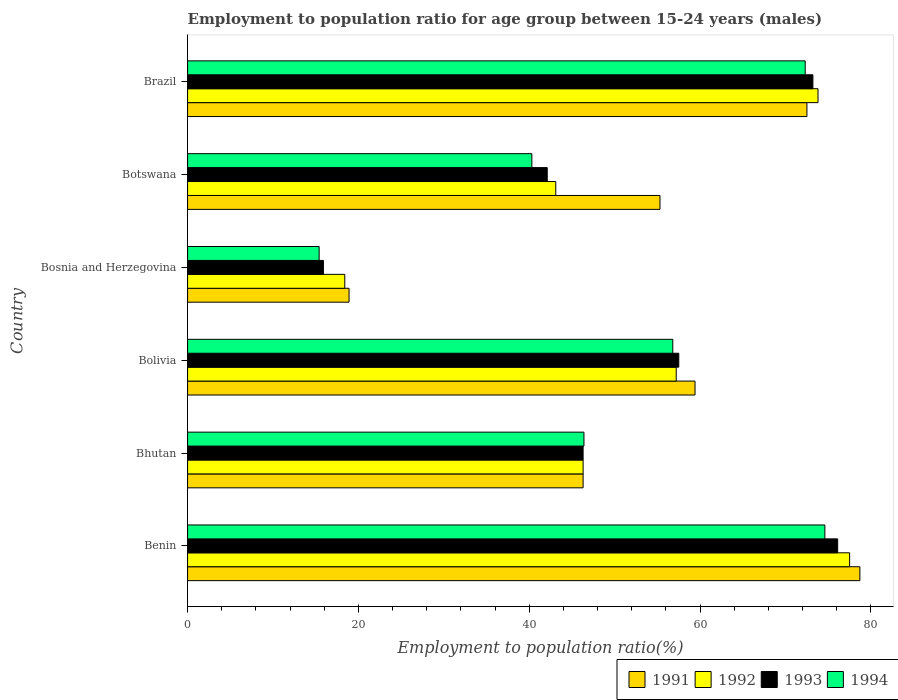How many groups of bars are there?
Keep it short and to the point. 6. How many bars are there on the 6th tick from the bottom?
Your answer should be very brief. 4. What is the label of the 3rd group of bars from the top?
Keep it short and to the point. Bosnia and Herzegovina. In how many cases, is the number of bars for a given country not equal to the number of legend labels?
Your answer should be compact. 0. What is the employment to population ratio in 1994 in Bolivia?
Provide a short and direct response. 56.8. Across all countries, what is the maximum employment to population ratio in 1994?
Provide a short and direct response. 74.6. Across all countries, what is the minimum employment to population ratio in 1992?
Provide a succinct answer. 18.4. In which country was the employment to population ratio in 1992 maximum?
Provide a short and direct response. Benin. In which country was the employment to population ratio in 1992 minimum?
Give a very brief answer. Bosnia and Herzegovina. What is the total employment to population ratio in 1992 in the graph?
Provide a succinct answer. 316.3. What is the difference between the employment to population ratio in 1994 in Bhutan and that in Botswana?
Give a very brief answer. 6.1. What is the difference between the employment to population ratio in 1992 in Bhutan and the employment to population ratio in 1991 in Brazil?
Make the answer very short. -26.2. What is the average employment to population ratio in 1992 per country?
Make the answer very short. 52.72. What is the difference between the employment to population ratio in 1994 and employment to population ratio in 1993 in Bosnia and Herzegovina?
Make the answer very short. -0.5. What is the ratio of the employment to population ratio in 1992 in Benin to that in Bolivia?
Your answer should be compact. 1.35. Is the employment to population ratio in 1991 in Bolivia less than that in Botswana?
Offer a terse response. No. Is the difference between the employment to population ratio in 1994 in Bolivia and Bosnia and Herzegovina greater than the difference between the employment to population ratio in 1993 in Bolivia and Bosnia and Herzegovina?
Offer a very short reply. No. What is the difference between the highest and the second highest employment to population ratio in 1993?
Offer a terse response. 2.9. What is the difference between the highest and the lowest employment to population ratio in 1993?
Provide a succinct answer. 60.2. Is it the case that in every country, the sum of the employment to population ratio in 1991 and employment to population ratio in 1994 is greater than the sum of employment to population ratio in 1992 and employment to population ratio in 1993?
Provide a succinct answer. No. What does the 3rd bar from the top in Bosnia and Herzegovina represents?
Ensure brevity in your answer.  1992. What does the 2nd bar from the bottom in Bolivia represents?
Your answer should be very brief. 1992. What is the difference between two consecutive major ticks on the X-axis?
Provide a succinct answer. 20. Are the values on the major ticks of X-axis written in scientific E-notation?
Make the answer very short. No. Does the graph contain grids?
Keep it short and to the point. No. Where does the legend appear in the graph?
Keep it short and to the point. Bottom right. What is the title of the graph?
Offer a terse response. Employment to population ratio for age group between 15-24 years (males). What is the label or title of the X-axis?
Your response must be concise. Employment to population ratio(%). What is the Employment to population ratio(%) of 1991 in Benin?
Offer a terse response. 78.7. What is the Employment to population ratio(%) in 1992 in Benin?
Provide a short and direct response. 77.5. What is the Employment to population ratio(%) of 1993 in Benin?
Your answer should be very brief. 76.1. What is the Employment to population ratio(%) in 1994 in Benin?
Your answer should be compact. 74.6. What is the Employment to population ratio(%) in 1991 in Bhutan?
Make the answer very short. 46.3. What is the Employment to population ratio(%) of 1992 in Bhutan?
Give a very brief answer. 46.3. What is the Employment to population ratio(%) of 1993 in Bhutan?
Give a very brief answer. 46.3. What is the Employment to population ratio(%) of 1994 in Bhutan?
Ensure brevity in your answer.  46.4. What is the Employment to population ratio(%) of 1991 in Bolivia?
Keep it short and to the point. 59.4. What is the Employment to population ratio(%) of 1992 in Bolivia?
Offer a terse response. 57.2. What is the Employment to population ratio(%) in 1993 in Bolivia?
Give a very brief answer. 57.5. What is the Employment to population ratio(%) in 1994 in Bolivia?
Make the answer very short. 56.8. What is the Employment to population ratio(%) of 1991 in Bosnia and Herzegovina?
Your response must be concise. 18.9. What is the Employment to population ratio(%) in 1992 in Bosnia and Herzegovina?
Your answer should be very brief. 18.4. What is the Employment to population ratio(%) of 1993 in Bosnia and Herzegovina?
Make the answer very short. 15.9. What is the Employment to population ratio(%) in 1994 in Bosnia and Herzegovina?
Your response must be concise. 15.4. What is the Employment to population ratio(%) in 1991 in Botswana?
Keep it short and to the point. 55.3. What is the Employment to population ratio(%) in 1992 in Botswana?
Your answer should be very brief. 43.1. What is the Employment to population ratio(%) in 1993 in Botswana?
Offer a very short reply. 42.1. What is the Employment to population ratio(%) of 1994 in Botswana?
Provide a succinct answer. 40.3. What is the Employment to population ratio(%) in 1991 in Brazil?
Give a very brief answer. 72.5. What is the Employment to population ratio(%) of 1992 in Brazil?
Your answer should be compact. 73.8. What is the Employment to population ratio(%) in 1993 in Brazil?
Provide a succinct answer. 73.2. What is the Employment to population ratio(%) in 1994 in Brazil?
Your answer should be very brief. 72.3. Across all countries, what is the maximum Employment to population ratio(%) of 1991?
Your answer should be very brief. 78.7. Across all countries, what is the maximum Employment to population ratio(%) in 1992?
Your answer should be compact. 77.5. Across all countries, what is the maximum Employment to population ratio(%) of 1993?
Offer a terse response. 76.1. Across all countries, what is the maximum Employment to population ratio(%) in 1994?
Your answer should be very brief. 74.6. Across all countries, what is the minimum Employment to population ratio(%) in 1991?
Keep it short and to the point. 18.9. Across all countries, what is the minimum Employment to population ratio(%) of 1992?
Ensure brevity in your answer.  18.4. Across all countries, what is the minimum Employment to population ratio(%) in 1993?
Offer a very short reply. 15.9. Across all countries, what is the minimum Employment to population ratio(%) of 1994?
Your response must be concise. 15.4. What is the total Employment to population ratio(%) in 1991 in the graph?
Provide a succinct answer. 331.1. What is the total Employment to population ratio(%) in 1992 in the graph?
Provide a short and direct response. 316.3. What is the total Employment to population ratio(%) of 1993 in the graph?
Your answer should be very brief. 311.1. What is the total Employment to population ratio(%) in 1994 in the graph?
Ensure brevity in your answer.  305.8. What is the difference between the Employment to population ratio(%) in 1991 in Benin and that in Bhutan?
Ensure brevity in your answer.  32.4. What is the difference between the Employment to population ratio(%) of 1992 in Benin and that in Bhutan?
Provide a succinct answer. 31.2. What is the difference between the Employment to population ratio(%) in 1993 in Benin and that in Bhutan?
Provide a succinct answer. 29.8. What is the difference between the Employment to population ratio(%) of 1994 in Benin and that in Bhutan?
Ensure brevity in your answer.  28.2. What is the difference between the Employment to population ratio(%) of 1991 in Benin and that in Bolivia?
Provide a short and direct response. 19.3. What is the difference between the Employment to population ratio(%) of 1992 in Benin and that in Bolivia?
Give a very brief answer. 20.3. What is the difference between the Employment to population ratio(%) in 1993 in Benin and that in Bolivia?
Ensure brevity in your answer.  18.6. What is the difference between the Employment to population ratio(%) in 1991 in Benin and that in Bosnia and Herzegovina?
Offer a very short reply. 59.8. What is the difference between the Employment to population ratio(%) of 1992 in Benin and that in Bosnia and Herzegovina?
Offer a terse response. 59.1. What is the difference between the Employment to population ratio(%) in 1993 in Benin and that in Bosnia and Herzegovina?
Ensure brevity in your answer.  60.2. What is the difference between the Employment to population ratio(%) in 1994 in Benin and that in Bosnia and Herzegovina?
Your answer should be very brief. 59.2. What is the difference between the Employment to population ratio(%) of 1991 in Benin and that in Botswana?
Offer a very short reply. 23.4. What is the difference between the Employment to population ratio(%) of 1992 in Benin and that in Botswana?
Offer a terse response. 34.4. What is the difference between the Employment to population ratio(%) of 1994 in Benin and that in Botswana?
Offer a terse response. 34.3. What is the difference between the Employment to population ratio(%) of 1991 in Benin and that in Brazil?
Provide a succinct answer. 6.2. What is the difference between the Employment to population ratio(%) of 1992 in Benin and that in Brazil?
Your answer should be compact. 3.7. What is the difference between the Employment to population ratio(%) of 1993 in Benin and that in Brazil?
Provide a succinct answer. 2.9. What is the difference between the Employment to population ratio(%) of 1992 in Bhutan and that in Bolivia?
Give a very brief answer. -10.9. What is the difference between the Employment to population ratio(%) of 1993 in Bhutan and that in Bolivia?
Make the answer very short. -11.2. What is the difference between the Employment to population ratio(%) of 1991 in Bhutan and that in Bosnia and Herzegovina?
Keep it short and to the point. 27.4. What is the difference between the Employment to population ratio(%) of 1992 in Bhutan and that in Bosnia and Herzegovina?
Offer a terse response. 27.9. What is the difference between the Employment to population ratio(%) of 1993 in Bhutan and that in Bosnia and Herzegovina?
Offer a very short reply. 30.4. What is the difference between the Employment to population ratio(%) of 1994 in Bhutan and that in Bosnia and Herzegovina?
Your response must be concise. 31. What is the difference between the Employment to population ratio(%) of 1991 in Bhutan and that in Botswana?
Your answer should be compact. -9. What is the difference between the Employment to population ratio(%) in 1992 in Bhutan and that in Botswana?
Your response must be concise. 3.2. What is the difference between the Employment to population ratio(%) of 1994 in Bhutan and that in Botswana?
Keep it short and to the point. 6.1. What is the difference between the Employment to population ratio(%) of 1991 in Bhutan and that in Brazil?
Offer a very short reply. -26.2. What is the difference between the Employment to population ratio(%) in 1992 in Bhutan and that in Brazil?
Your response must be concise. -27.5. What is the difference between the Employment to population ratio(%) of 1993 in Bhutan and that in Brazil?
Keep it short and to the point. -26.9. What is the difference between the Employment to population ratio(%) of 1994 in Bhutan and that in Brazil?
Your answer should be very brief. -25.9. What is the difference between the Employment to population ratio(%) in 1991 in Bolivia and that in Bosnia and Herzegovina?
Your answer should be compact. 40.5. What is the difference between the Employment to population ratio(%) in 1992 in Bolivia and that in Bosnia and Herzegovina?
Provide a succinct answer. 38.8. What is the difference between the Employment to population ratio(%) of 1993 in Bolivia and that in Bosnia and Herzegovina?
Your answer should be compact. 41.6. What is the difference between the Employment to population ratio(%) of 1994 in Bolivia and that in Bosnia and Herzegovina?
Ensure brevity in your answer.  41.4. What is the difference between the Employment to population ratio(%) of 1991 in Bolivia and that in Botswana?
Offer a terse response. 4.1. What is the difference between the Employment to population ratio(%) of 1993 in Bolivia and that in Botswana?
Give a very brief answer. 15.4. What is the difference between the Employment to population ratio(%) in 1992 in Bolivia and that in Brazil?
Keep it short and to the point. -16.6. What is the difference between the Employment to population ratio(%) of 1993 in Bolivia and that in Brazil?
Provide a succinct answer. -15.7. What is the difference between the Employment to population ratio(%) of 1994 in Bolivia and that in Brazil?
Offer a terse response. -15.5. What is the difference between the Employment to population ratio(%) in 1991 in Bosnia and Herzegovina and that in Botswana?
Provide a succinct answer. -36.4. What is the difference between the Employment to population ratio(%) in 1992 in Bosnia and Herzegovina and that in Botswana?
Give a very brief answer. -24.7. What is the difference between the Employment to population ratio(%) of 1993 in Bosnia and Herzegovina and that in Botswana?
Provide a short and direct response. -26.2. What is the difference between the Employment to population ratio(%) in 1994 in Bosnia and Herzegovina and that in Botswana?
Make the answer very short. -24.9. What is the difference between the Employment to population ratio(%) of 1991 in Bosnia and Herzegovina and that in Brazil?
Your answer should be compact. -53.6. What is the difference between the Employment to population ratio(%) of 1992 in Bosnia and Herzegovina and that in Brazil?
Give a very brief answer. -55.4. What is the difference between the Employment to population ratio(%) in 1993 in Bosnia and Herzegovina and that in Brazil?
Offer a very short reply. -57.3. What is the difference between the Employment to population ratio(%) of 1994 in Bosnia and Herzegovina and that in Brazil?
Offer a very short reply. -56.9. What is the difference between the Employment to population ratio(%) of 1991 in Botswana and that in Brazil?
Provide a succinct answer. -17.2. What is the difference between the Employment to population ratio(%) of 1992 in Botswana and that in Brazil?
Make the answer very short. -30.7. What is the difference between the Employment to population ratio(%) of 1993 in Botswana and that in Brazil?
Offer a very short reply. -31.1. What is the difference between the Employment to population ratio(%) in 1994 in Botswana and that in Brazil?
Your answer should be very brief. -32. What is the difference between the Employment to population ratio(%) of 1991 in Benin and the Employment to population ratio(%) of 1992 in Bhutan?
Your response must be concise. 32.4. What is the difference between the Employment to population ratio(%) of 1991 in Benin and the Employment to population ratio(%) of 1993 in Bhutan?
Provide a succinct answer. 32.4. What is the difference between the Employment to population ratio(%) of 1991 in Benin and the Employment to population ratio(%) of 1994 in Bhutan?
Your answer should be compact. 32.3. What is the difference between the Employment to population ratio(%) in 1992 in Benin and the Employment to population ratio(%) in 1993 in Bhutan?
Ensure brevity in your answer.  31.2. What is the difference between the Employment to population ratio(%) of 1992 in Benin and the Employment to population ratio(%) of 1994 in Bhutan?
Ensure brevity in your answer.  31.1. What is the difference between the Employment to population ratio(%) of 1993 in Benin and the Employment to population ratio(%) of 1994 in Bhutan?
Offer a very short reply. 29.7. What is the difference between the Employment to population ratio(%) of 1991 in Benin and the Employment to population ratio(%) of 1992 in Bolivia?
Your answer should be very brief. 21.5. What is the difference between the Employment to population ratio(%) in 1991 in Benin and the Employment to population ratio(%) in 1993 in Bolivia?
Your response must be concise. 21.2. What is the difference between the Employment to population ratio(%) in 1991 in Benin and the Employment to population ratio(%) in 1994 in Bolivia?
Provide a succinct answer. 21.9. What is the difference between the Employment to population ratio(%) in 1992 in Benin and the Employment to population ratio(%) in 1994 in Bolivia?
Provide a short and direct response. 20.7. What is the difference between the Employment to population ratio(%) of 1993 in Benin and the Employment to population ratio(%) of 1994 in Bolivia?
Provide a succinct answer. 19.3. What is the difference between the Employment to population ratio(%) of 1991 in Benin and the Employment to population ratio(%) of 1992 in Bosnia and Herzegovina?
Your answer should be compact. 60.3. What is the difference between the Employment to population ratio(%) of 1991 in Benin and the Employment to population ratio(%) of 1993 in Bosnia and Herzegovina?
Provide a short and direct response. 62.8. What is the difference between the Employment to population ratio(%) in 1991 in Benin and the Employment to population ratio(%) in 1994 in Bosnia and Herzegovina?
Offer a very short reply. 63.3. What is the difference between the Employment to population ratio(%) of 1992 in Benin and the Employment to population ratio(%) of 1993 in Bosnia and Herzegovina?
Offer a terse response. 61.6. What is the difference between the Employment to population ratio(%) of 1992 in Benin and the Employment to population ratio(%) of 1994 in Bosnia and Herzegovina?
Your answer should be very brief. 62.1. What is the difference between the Employment to population ratio(%) in 1993 in Benin and the Employment to population ratio(%) in 1994 in Bosnia and Herzegovina?
Ensure brevity in your answer.  60.7. What is the difference between the Employment to population ratio(%) in 1991 in Benin and the Employment to population ratio(%) in 1992 in Botswana?
Offer a terse response. 35.6. What is the difference between the Employment to population ratio(%) of 1991 in Benin and the Employment to population ratio(%) of 1993 in Botswana?
Make the answer very short. 36.6. What is the difference between the Employment to population ratio(%) in 1991 in Benin and the Employment to population ratio(%) in 1994 in Botswana?
Offer a terse response. 38.4. What is the difference between the Employment to population ratio(%) of 1992 in Benin and the Employment to population ratio(%) of 1993 in Botswana?
Your answer should be compact. 35.4. What is the difference between the Employment to population ratio(%) of 1992 in Benin and the Employment to population ratio(%) of 1994 in Botswana?
Give a very brief answer. 37.2. What is the difference between the Employment to population ratio(%) in 1993 in Benin and the Employment to population ratio(%) in 1994 in Botswana?
Your response must be concise. 35.8. What is the difference between the Employment to population ratio(%) in 1991 in Benin and the Employment to population ratio(%) in 1992 in Brazil?
Provide a short and direct response. 4.9. What is the difference between the Employment to population ratio(%) in 1991 in Benin and the Employment to population ratio(%) in 1993 in Brazil?
Offer a very short reply. 5.5. What is the difference between the Employment to population ratio(%) in 1992 in Benin and the Employment to population ratio(%) in 1994 in Brazil?
Make the answer very short. 5.2. What is the difference between the Employment to population ratio(%) of 1993 in Benin and the Employment to population ratio(%) of 1994 in Brazil?
Offer a terse response. 3.8. What is the difference between the Employment to population ratio(%) of 1991 in Bhutan and the Employment to population ratio(%) of 1994 in Bolivia?
Your answer should be very brief. -10.5. What is the difference between the Employment to population ratio(%) in 1993 in Bhutan and the Employment to population ratio(%) in 1994 in Bolivia?
Give a very brief answer. -10.5. What is the difference between the Employment to population ratio(%) of 1991 in Bhutan and the Employment to population ratio(%) of 1992 in Bosnia and Herzegovina?
Provide a short and direct response. 27.9. What is the difference between the Employment to population ratio(%) of 1991 in Bhutan and the Employment to population ratio(%) of 1993 in Bosnia and Herzegovina?
Provide a succinct answer. 30.4. What is the difference between the Employment to population ratio(%) of 1991 in Bhutan and the Employment to population ratio(%) of 1994 in Bosnia and Herzegovina?
Give a very brief answer. 30.9. What is the difference between the Employment to population ratio(%) of 1992 in Bhutan and the Employment to population ratio(%) of 1993 in Bosnia and Herzegovina?
Give a very brief answer. 30.4. What is the difference between the Employment to population ratio(%) of 1992 in Bhutan and the Employment to population ratio(%) of 1994 in Bosnia and Herzegovina?
Ensure brevity in your answer.  30.9. What is the difference between the Employment to population ratio(%) of 1993 in Bhutan and the Employment to population ratio(%) of 1994 in Bosnia and Herzegovina?
Provide a succinct answer. 30.9. What is the difference between the Employment to population ratio(%) of 1991 in Bhutan and the Employment to population ratio(%) of 1993 in Botswana?
Your answer should be very brief. 4.2. What is the difference between the Employment to population ratio(%) in 1991 in Bhutan and the Employment to population ratio(%) in 1994 in Botswana?
Provide a short and direct response. 6. What is the difference between the Employment to population ratio(%) in 1992 in Bhutan and the Employment to population ratio(%) in 1994 in Botswana?
Give a very brief answer. 6. What is the difference between the Employment to population ratio(%) of 1991 in Bhutan and the Employment to population ratio(%) of 1992 in Brazil?
Ensure brevity in your answer.  -27.5. What is the difference between the Employment to population ratio(%) in 1991 in Bhutan and the Employment to population ratio(%) in 1993 in Brazil?
Your answer should be compact. -26.9. What is the difference between the Employment to population ratio(%) in 1992 in Bhutan and the Employment to population ratio(%) in 1993 in Brazil?
Make the answer very short. -26.9. What is the difference between the Employment to population ratio(%) in 1991 in Bolivia and the Employment to population ratio(%) in 1993 in Bosnia and Herzegovina?
Offer a terse response. 43.5. What is the difference between the Employment to population ratio(%) in 1992 in Bolivia and the Employment to population ratio(%) in 1993 in Bosnia and Herzegovina?
Offer a terse response. 41.3. What is the difference between the Employment to population ratio(%) of 1992 in Bolivia and the Employment to population ratio(%) of 1994 in Bosnia and Herzegovina?
Keep it short and to the point. 41.8. What is the difference between the Employment to population ratio(%) in 1993 in Bolivia and the Employment to population ratio(%) in 1994 in Bosnia and Herzegovina?
Give a very brief answer. 42.1. What is the difference between the Employment to population ratio(%) in 1991 in Bolivia and the Employment to population ratio(%) in 1992 in Botswana?
Ensure brevity in your answer.  16.3. What is the difference between the Employment to population ratio(%) in 1992 in Bolivia and the Employment to population ratio(%) in 1993 in Botswana?
Give a very brief answer. 15.1. What is the difference between the Employment to population ratio(%) in 1991 in Bolivia and the Employment to population ratio(%) in 1992 in Brazil?
Provide a short and direct response. -14.4. What is the difference between the Employment to population ratio(%) of 1992 in Bolivia and the Employment to population ratio(%) of 1994 in Brazil?
Make the answer very short. -15.1. What is the difference between the Employment to population ratio(%) in 1993 in Bolivia and the Employment to population ratio(%) in 1994 in Brazil?
Provide a short and direct response. -14.8. What is the difference between the Employment to population ratio(%) of 1991 in Bosnia and Herzegovina and the Employment to population ratio(%) of 1992 in Botswana?
Offer a terse response. -24.2. What is the difference between the Employment to population ratio(%) in 1991 in Bosnia and Herzegovina and the Employment to population ratio(%) in 1993 in Botswana?
Your answer should be very brief. -23.2. What is the difference between the Employment to population ratio(%) in 1991 in Bosnia and Herzegovina and the Employment to population ratio(%) in 1994 in Botswana?
Offer a very short reply. -21.4. What is the difference between the Employment to population ratio(%) in 1992 in Bosnia and Herzegovina and the Employment to population ratio(%) in 1993 in Botswana?
Provide a succinct answer. -23.7. What is the difference between the Employment to population ratio(%) in 1992 in Bosnia and Herzegovina and the Employment to population ratio(%) in 1994 in Botswana?
Offer a very short reply. -21.9. What is the difference between the Employment to population ratio(%) in 1993 in Bosnia and Herzegovina and the Employment to population ratio(%) in 1994 in Botswana?
Offer a very short reply. -24.4. What is the difference between the Employment to population ratio(%) in 1991 in Bosnia and Herzegovina and the Employment to population ratio(%) in 1992 in Brazil?
Your answer should be very brief. -54.9. What is the difference between the Employment to population ratio(%) in 1991 in Bosnia and Herzegovina and the Employment to population ratio(%) in 1993 in Brazil?
Keep it short and to the point. -54.3. What is the difference between the Employment to population ratio(%) of 1991 in Bosnia and Herzegovina and the Employment to population ratio(%) of 1994 in Brazil?
Make the answer very short. -53.4. What is the difference between the Employment to population ratio(%) of 1992 in Bosnia and Herzegovina and the Employment to population ratio(%) of 1993 in Brazil?
Give a very brief answer. -54.8. What is the difference between the Employment to population ratio(%) in 1992 in Bosnia and Herzegovina and the Employment to population ratio(%) in 1994 in Brazil?
Your answer should be compact. -53.9. What is the difference between the Employment to population ratio(%) of 1993 in Bosnia and Herzegovina and the Employment to population ratio(%) of 1994 in Brazil?
Make the answer very short. -56.4. What is the difference between the Employment to population ratio(%) in 1991 in Botswana and the Employment to population ratio(%) in 1992 in Brazil?
Provide a succinct answer. -18.5. What is the difference between the Employment to population ratio(%) of 1991 in Botswana and the Employment to population ratio(%) of 1993 in Brazil?
Ensure brevity in your answer.  -17.9. What is the difference between the Employment to population ratio(%) of 1992 in Botswana and the Employment to population ratio(%) of 1993 in Brazil?
Offer a terse response. -30.1. What is the difference between the Employment to population ratio(%) of 1992 in Botswana and the Employment to population ratio(%) of 1994 in Brazil?
Provide a succinct answer. -29.2. What is the difference between the Employment to population ratio(%) in 1993 in Botswana and the Employment to population ratio(%) in 1994 in Brazil?
Keep it short and to the point. -30.2. What is the average Employment to population ratio(%) of 1991 per country?
Your answer should be very brief. 55.18. What is the average Employment to population ratio(%) of 1992 per country?
Provide a short and direct response. 52.72. What is the average Employment to population ratio(%) of 1993 per country?
Make the answer very short. 51.85. What is the average Employment to population ratio(%) in 1994 per country?
Ensure brevity in your answer.  50.97. What is the difference between the Employment to population ratio(%) of 1992 and Employment to population ratio(%) of 1993 in Benin?
Provide a short and direct response. 1.4. What is the difference between the Employment to population ratio(%) in 1992 and Employment to population ratio(%) in 1994 in Benin?
Your answer should be very brief. 2.9. What is the difference between the Employment to population ratio(%) in 1991 and Employment to population ratio(%) in 1993 in Bhutan?
Ensure brevity in your answer.  0. What is the difference between the Employment to population ratio(%) in 1992 and Employment to population ratio(%) in 1993 in Bhutan?
Provide a short and direct response. 0. What is the difference between the Employment to population ratio(%) in 1993 and Employment to population ratio(%) in 1994 in Bhutan?
Your response must be concise. -0.1. What is the difference between the Employment to population ratio(%) in 1991 and Employment to population ratio(%) in 1992 in Bolivia?
Offer a very short reply. 2.2. What is the difference between the Employment to population ratio(%) of 1991 and Employment to population ratio(%) of 1993 in Bolivia?
Offer a very short reply. 1.9. What is the difference between the Employment to population ratio(%) in 1991 and Employment to population ratio(%) in 1992 in Bosnia and Herzegovina?
Ensure brevity in your answer.  0.5. What is the difference between the Employment to population ratio(%) in 1993 and Employment to population ratio(%) in 1994 in Bosnia and Herzegovina?
Provide a succinct answer. 0.5. What is the difference between the Employment to population ratio(%) in 1991 and Employment to population ratio(%) in 1992 in Botswana?
Give a very brief answer. 12.2. What is the difference between the Employment to population ratio(%) of 1991 and Employment to population ratio(%) of 1994 in Botswana?
Give a very brief answer. 15. What is the difference between the Employment to population ratio(%) in 1993 and Employment to population ratio(%) in 1994 in Botswana?
Offer a very short reply. 1.8. What is the difference between the Employment to population ratio(%) in 1991 and Employment to population ratio(%) in 1992 in Brazil?
Your answer should be very brief. -1.3. What is the difference between the Employment to population ratio(%) in 1991 and Employment to population ratio(%) in 1993 in Brazil?
Keep it short and to the point. -0.7. What is the difference between the Employment to population ratio(%) in 1991 and Employment to population ratio(%) in 1994 in Brazil?
Your response must be concise. 0.2. What is the difference between the Employment to population ratio(%) in 1992 and Employment to population ratio(%) in 1994 in Brazil?
Ensure brevity in your answer.  1.5. What is the difference between the Employment to population ratio(%) in 1993 and Employment to population ratio(%) in 1994 in Brazil?
Offer a terse response. 0.9. What is the ratio of the Employment to population ratio(%) in 1991 in Benin to that in Bhutan?
Make the answer very short. 1.7. What is the ratio of the Employment to population ratio(%) of 1992 in Benin to that in Bhutan?
Offer a very short reply. 1.67. What is the ratio of the Employment to population ratio(%) in 1993 in Benin to that in Bhutan?
Give a very brief answer. 1.64. What is the ratio of the Employment to population ratio(%) in 1994 in Benin to that in Bhutan?
Ensure brevity in your answer.  1.61. What is the ratio of the Employment to population ratio(%) in 1991 in Benin to that in Bolivia?
Keep it short and to the point. 1.32. What is the ratio of the Employment to population ratio(%) in 1992 in Benin to that in Bolivia?
Give a very brief answer. 1.35. What is the ratio of the Employment to population ratio(%) in 1993 in Benin to that in Bolivia?
Offer a very short reply. 1.32. What is the ratio of the Employment to population ratio(%) of 1994 in Benin to that in Bolivia?
Keep it short and to the point. 1.31. What is the ratio of the Employment to population ratio(%) of 1991 in Benin to that in Bosnia and Herzegovina?
Your response must be concise. 4.16. What is the ratio of the Employment to population ratio(%) in 1992 in Benin to that in Bosnia and Herzegovina?
Provide a short and direct response. 4.21. What is the ratio of the Employment to population ratio(%) in 1993 in Benin to that in Bosnia and Herzegovina?
Provide a short and direct response. 4.79. What is the ratio of the Employment to population ratio(%) of 1994 in Benin to that in Bosnia and Herzegovina?
Make the answer very short. 4.84. What is the ratio of the Employment to population ratio(%) in 1991 in Benin to that in Botswana?
Your response must be concise. 1.42. What is the ratio of the Employment to population ratio(%) in 1992 in Benin to that in Botswana?
Ensure brevity in your answer.  1.8. What is the ratio of the Employment to population ratio(%) of 1993 in Benin to that in Botswana?
Give a very brief answer. 1.81. What is the ratio of the Employment to population ratio(%) of 1994 in Benin to that in Botswana?
Provide a short and direct response. 1.85. What is the ratio of the Employment to population ratio(%) in 1991 in Benin to that in Brazil?
Offer a terse response. 1.09. What is the ratio of the Employment to population ratio(%) in 1992 in Benin to that in Brazil?
Give a very brief answer. 1.05. What is the ratio of the Employment to population ratio(%) in 1993 in Benin to that in Brazil?
Offer a terse response. 1.04. What is the ratio of the Employment to population ratio(%) in 1994 in Benin to that in Brazil?
Make the answer very short. 1.03. What is the ratio of the Employment to population ratio(%) of 1991 in Bhutan to that in Bolivia?
Your answer should be very brief. 0.78. What is the ratio of the Employment to population ratio(%) of 1992 in Bhutan to that in Bolivia?
Provide a succinct answer. 0.81. What is the ratio of the Employment to population ratio(%) in 1993 in Bhutan to that in Bolivia?
Make the answer very short. 0.81. What is the ratio of the Employment to population ratio(%) of 1994 in Bhutan to that in Bolivia?
Ensure brevity in your answer.  0.82. What is the ratio of the Employment to population ratio(%) of 1991 in Bhutan to that in Bosnia and Herzegovina?
Your response must be concise. 2.45. What is the ratio of the Employment to population ratio(%) of 1992 in Bhutan to that in Bosnia and Herzegovina?
Offer a very short reply. 2.52. What is the ratio of the Employment to population ratio(%) in 1993 in Bhutan to that in Bosnia and Herzegovina?
Your response must be concise. 2.91. What is the ratio of the Employment to population ratio(%) of 1994 in Bhutan to that in Bosnia and Herzegovina?
Provide a succinct answer. 3.01. What is the ratio of the Employment to population ratio(%) in 1991 in Bhutan to that in Botswana?
Offer a very short reply. 0.84. What is the ratio of the Employment to population ratio(%) of 1992 in Bhutan to that in Botswana?
Your answer should be compact. 1.07. What is the ratio of the Employment to population ratio(%) of 1993 in Bhutan to that in Botswana?
Ensure brevity in your answer.  1.1. What is the ratio of the Employment to population ratio(%) of 1994 in Bhutan to that in Botswana?
Ensure brevity in your answer.  1.15. What is the ratio of the Employment to population ratio(%) of 1991 in Bhutan to that in Brazil?
Make the answer very short. 0.64. What is the ratio of the Employment to population ratio(%) of 1992 in Bhutan to that in Brazil?
Keep it short and to the point. 0.63. What is the ratio of the Employment to population ratio(%) of 1993 in Bhutan to that in Brazil?
Provide a succinct answer. 0.63. What is the ratio of the Employment to population ratio(%) in 1994 in Bhutan to that in Brazil?
Give a very brief answer. 0.64. What is the ratio of the Employment to population ratio(%) of 1991 in Bolivia to that in Bosnia and Herzegovina?
Give a very brief answer. 3.14. What is the ratio of the Employment to population ratio(%) in 1992 in Bolivia to that in Bosnia and Herzegovina?
Make the answer very short. 3.11. What is the ratio of the Employment to population ratio(%) of 1993 in Bolivia to that in Bosnia and Herzegovina?
Your answer should be very brief. 3.62. What is the ratio of the Employment to population ratio(%) of 1994 in Bolivia to that in Bosnia and Herzegovina?
Your answer should be compact. 3.69. What is the ratio of the Employment to population ratio(%) of 1991 in Bolivia to that in Botswana?
Provide a succinct answer. 1.07. What is the ratio of the Employment to population ratio(%) in 1992 in Bolivia to that in Botswana?
Give a very brief answer. 1.33. What is the ratio of the Employment to population ratio(%) of 1993 in Bolivia to that in Botswana?
Give a very brief answer. 1.37. What is the ratio of the Employment to population ratio(%) of 1994 in Bolivia to that in Botswana?
Give a very brief answer. 1.41. What is the ratio of the Employment to population ratio(%) of 1991 in Bolivia to that in Brazil?
Your response must be concise. 0.82. What is the ratio of the Employment to population ratio(%) in 1992 in Bolivia to that in Brazil?
Your answer should be very brief. 0.78. What is the ratio of the Employment to population ratio(%) in 1993 in Bolivia to that in Brazil?
Give a very brief answer. 0.79. What is the ratio of the Employment to population ratio(%) in 1994 in Bolivia to that in Brazil?
Offer a very short reply. 0.79. What is the ratio of the Employment to population ratio(%) of 1991 in Bosnia and Herzegovina to that in Botswana?
Give a very brief answer. 0.34. What is the ratio of the Employment to population ratio(%) of 1992 in Bosnia and Herzegovina to that in Botswana?
Your response must be concise. 0.43. What is the ratio of the Employment to population ratio(%) of 1993 in Bosnia and Herzegovina to that in Botswana?
Your response must be concise. 0.38. What is the ratio of the Employment to population ratio(%) in 1994 in Bosnia and Herzegovina to that in Botswana?
Provide a succinct answer. 0.38. What is the ratio of the Employment to population ratio(%) of 1991 in Bosnia and Herzegovina to that in Brazil?
Make the answer very short. 0.26. What is the ratio of the Employment to population ratio(%) of 1992 in Bosnia and Herzegovina to that in Brazil?
Your answer should be compact. 0.25. What is the ratio of the Employment to population ratio(%) of 1993 in Bosnia and Herzegovina to that in Brazil?
Your answer should be compact. 0.22. What is the ratio of the Employment to population ratio(%) in 1994 in Bosnia and Herzegovina to that in Brazil?
Keep it short and to the point. 0.21. What is the ratio of the Employment to population ratio(%) in 1991 in Botswana to that in Brazil?
Your answer should be compact. 0.76. What is the ratio of the Employment to population ratio(%) in 1992 in Botswana to that in Brazil?
Offer a terse response. 0.58. What is the ratio of the Employment to population ratio(%) of 1993 in Botswana to that in Brazil?
Give a very brief answer. 0.58. What is the ratio of the Employment to population ratio(%) in 1994 in Botswana to that in Brazil?
Your response must be concise. 0.56. What is the difference between the highest and the second highest Employment to population ratio(%) in 1991?
Offer a very short reply. 6.2. What is the difference between the highest and the second highest Employment to population ratio(%) in 1994?
Your answer should be compact. 2.3. What is the difference between the highest and the lowest Employment to population ratio(%) of 1991?
Give a very brief answer. 59.8. What is the difference between the highest and the lowest Employment to population ratio(%) of 1992?
Ensure brevity in your answer.  59.1. What is the difference between the highest and the lowest Employment to population ratio(%) of 1993?
Provide a short and direct response. 60.2. What is the difference between the highest and the lowest Employment to population ratio(%) in 1994?
Give a very brief answer. 59.2. 